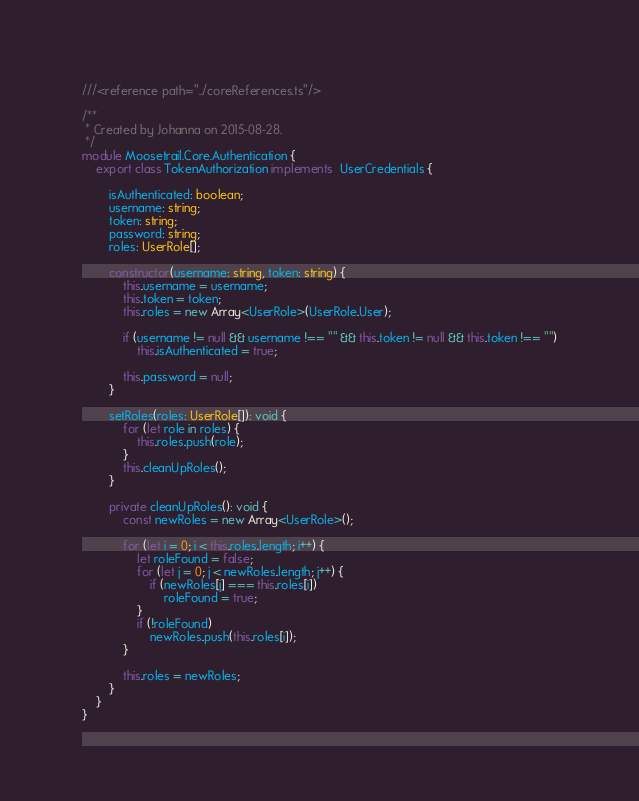Convert code to text. <code><loc_0><loc_0><loc_500><loc_500><_TypeScript_>///<reference path="../coreReferences.ts"/>

/**
 * Created by Johanna on 2015-08-28.
 */
module Moosetrail.Core.Authentication {
    export class TokenAuthorization implements  UserCredentials {

        isAuthenticated: boolean;
        username: string;
        token: string;
        password: string;
        roles: UserRole[];

        constructor(username: string, token: string) {
            this.username = username;
            this.token = token;
            this.roles = new Array<UserRole>(UserRole.User);

            if (username != null && username !== "" && this.token != null && this.token !== "")
                this.isAuthenticated = true;

            this.password = null;
        }

        setRoles(roles: UserRole[]): void {
            for (let role in roles) {
                this.roles.push(role);
            }
            this.cleanUpRoles();
        }

        private cleanUpRoles(): void {
            const newRoles = new Array<UserRole>();

            for (let i = 0; i < this.roles.length; i++) {
                let roleFound = false;
                for (let j = 0; j < newRoles.length; j++) {
                    if (newRoles[j] === this.roles[i])
                        roleFound = true;
                }
                if (!roleFound)
                    newRoles.push(this.roles[i]);
            }

            this.roles = newRoles;
        }
    }
}</code> 